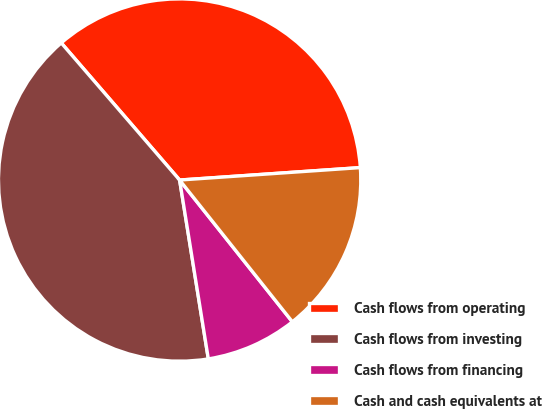Convert chart. <chart><loc_0><loc_0><loc_500><loc_500><pie_chart><fcel>Cash flows from operating<fcel>Cash flows from investing<fcel>Cash flows from financing<fcel>Cash and cash equivalents at<nl><fcel>35.24%<fcel>41.2%<fcel>8.16%<fcel>15.4%<nl></chart> 